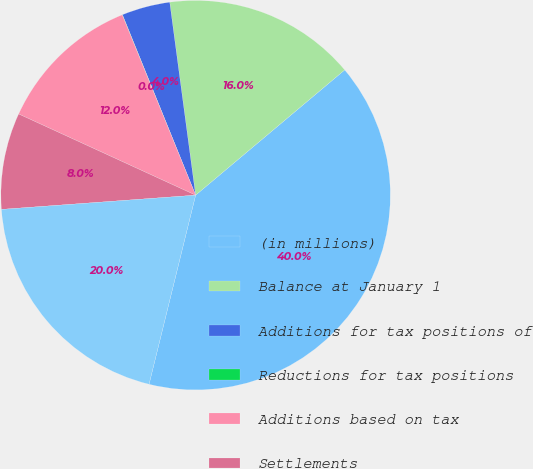<chart> <loc_0><loc_0><loc_500><loc_500><pie_chart><fcel>(in millions)<fcel>Balance at January 1<fcel>Additions for tax positions of<fcel>Reductions for tax positions<fcel>Additions based on tax<fcel>Settlements<fcel>Balance at December 31<nl><fcel>39.96%<fcel>16.0%<fcel>4.01%<fcel>0.02%<fcel>12.0%<fcel>8.01%<fcel>19.99%<nl></chart> 